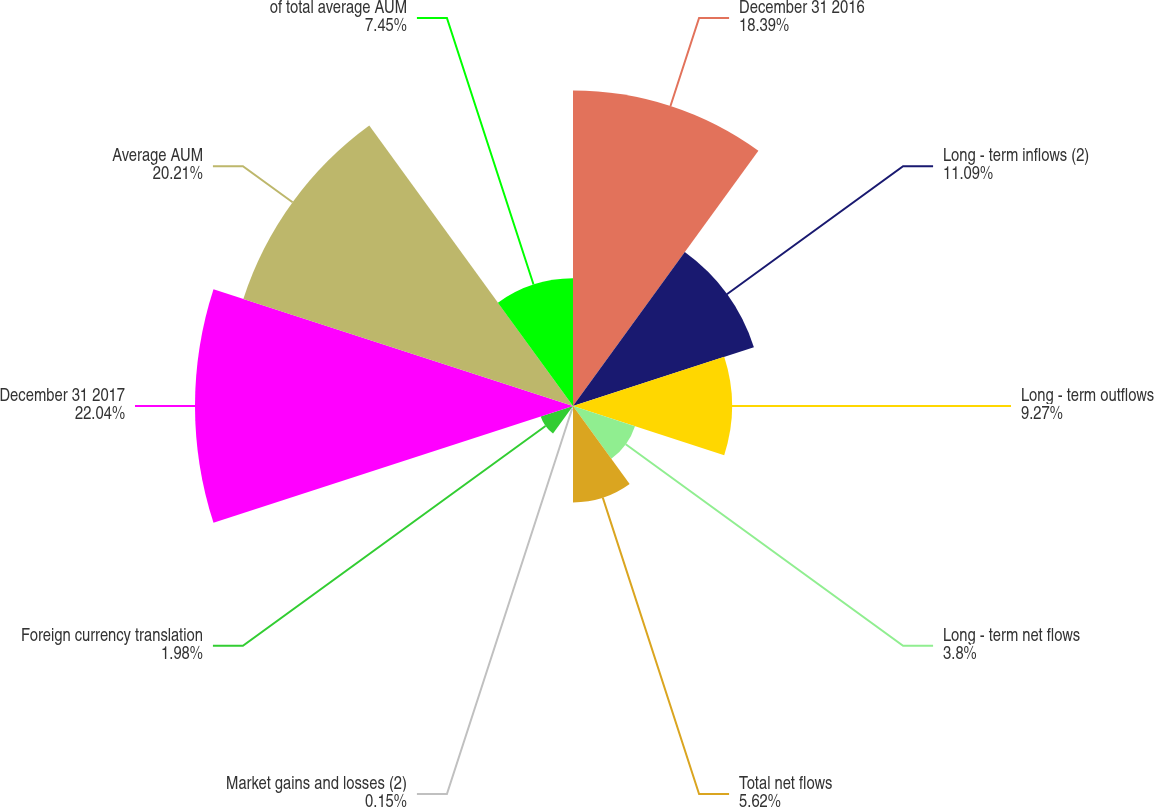<chart> <loc_0><loc_0><loc_500><loc_500><pie_chart><fcel>December 31 2016<fcel>Long - term inflows (2)<fcel>Long - term outflows<fcel>Long - term net flows<fcel>Total net flows<fcel>Market gains and losses (2)<fcel>Foreign currency translation<fcel>December 31 2017<fcel>Average AUM<fcel>of total average AUM<nl><fcel>18.39%<fcel>11.09%<fcel>9.27%<fcel>3.8%<fcel>5.62%<fcel>0.15%<fcel>1.98%<fcel>22.04%<fcel>20.21%<fcel>7.45%<nl></chart> 